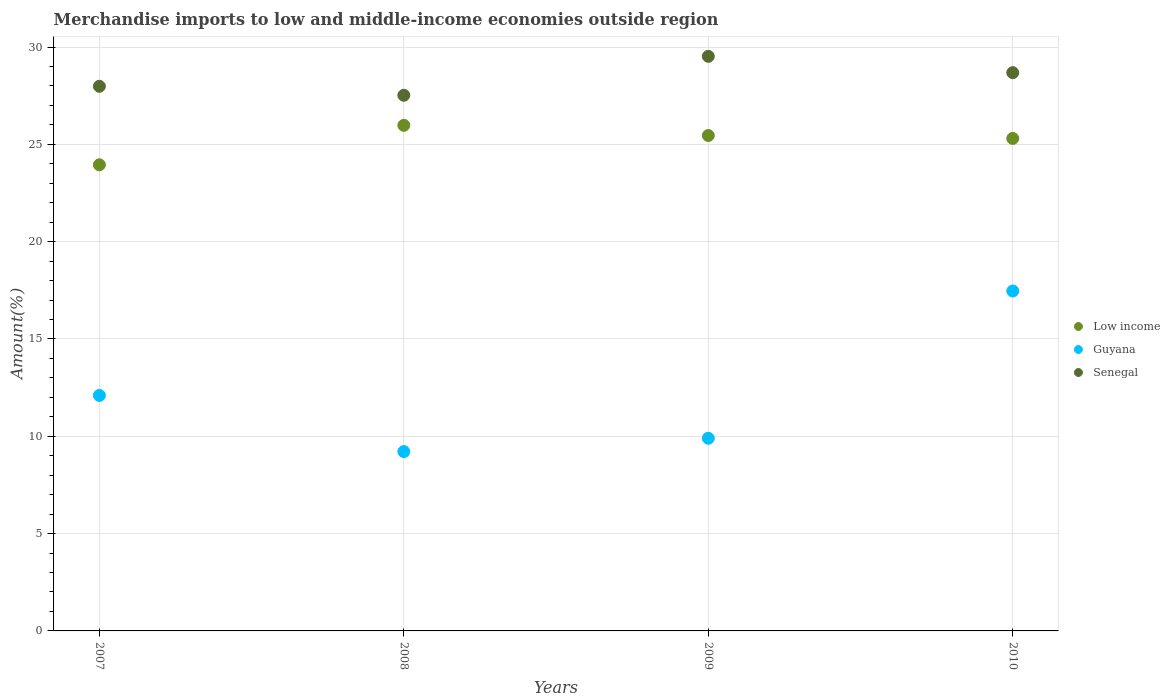How many different coloured dotlines are there?
Keep it short and to the point. 3. Is the number of dotlines equal to the number of legend labels?
Ensure brevity in your answer.  Yes. What is the percentage of amount earned from merchandise imports in Low income in 2008?
Offer a terse response. 25.98. Across all years, what is the maximum percentage of amount earned from merchandise imports in Senegal?
Provide a succinct answer. 29.52. Across all years, what is the minimum percentage of amount earned from merchandise imports in Guyana?
Keep it short and to the point. 9.22. In which year was the percentage of amount earned from merchandise imports in Senegal maximum?
Provide a succinct answer. 2009. In which year was the percentage of amount earned from merchandise imports in Guyana minimum?
Offer a very short reply. 2008. What is the total percentage of amount earned from merchandise imports in Low income in the graph?
Offer a terse response. 100.69. What is the difference between the percentage of amount earned from merchandise imports in Low income in 2009 and that in 2010?
Your answer should be compact. 0.15. What is the difference between the percentage of amount earned from merchandise imports in Low income in 2009 and the percentage of amount earned from merchandise imports in Guyana in 2008?
Your answer should be compact. 16.24. What is the average percentage of amount earned from merchandise imports in Low income per year?
Give a very brief answer. 25.17. In the year 2010, what is the difference between the percentage of amount earned from merchandise imports in Senegal and percentage of amount earned from merchandise imports in Guyana?
Give a very brief answer. 11.22. In how many years, is the percentage of amount earned from merchandise imports in Guyana greater than 28 %?
Give a very brief answer. 0. What is the ratio of the percentage of amount earned from merchandise imports in Guyana in 2009 to that in 2010?
Give a very brief answer. 0.57. Is the percentage of amount earned from merchandise imports in Senegal in 2007 less than that in 2009?
Offer a very short reply. Yes. Is the difference between the percentage of amount earned from merchandise imports in Senegal in 2008 and 2009 greater than the difference between the percentage of amount earned from merchandise imports in Guyana in 2008 and 2009?
Make the answer very short. No. What is the difference between the highest and the second highest percentage of amount earned from merchandise imports in Guyana?
Your response must be concise. 5.37. What is the difference between the highest and the lowest percentage of amount earned from merchandise imports in Guyana?
Provide a succinct answer. 8.25. In how many years, is the percentage of amount earned from merchandise imports in Low income greater than the average percentage of amount earned from merchandise imports in Low income taken over all years?
Make the answer very short. 3. Does the percentage of amount earned from merchandise imports in Guyana monotonically increase over the years?
Offer a very short reply. No. Is the percentage of amount earned from merchandise imports in Senegal strictly less than the percentage of amount earned from merchandise imports in Low income over the years?
Your response must be concise. No. How many years are there in the graph?
Make the answer very short. 4. Are the values on the major ticks of Y-axis written in scientific E-notation?
Give a very brief answer. No. How many legend labels are there?
Offer a terse response. 3. How are the legend labels stacked?
Make the answer very short. Vertical. What is the title of the graph?
Your answer should be very brief. Merchandise imports to low and middle-income economies outside region. Does "Namibia" appear as one of the legend labels in the graph?
Provide a succinct answer. No. What is the label or title of the X-axis?
Your answer should be compact. Years. What is the label or title of the Y-axis?
Provide a succinct answer. Amount(%). What is the Amount(%) of Low income in 2007?
Offer a very short reply. 23.95. What is the Amount(%) in Guyana in 2007?
Ensure brevity in your answer.  12.1. What is the Amount(%) in Senegal in 2007?
Provide a short and direct response. 27.99. What is the Amount(%) in Low income in 2008?
Make the answer very short. 25.98. What is the Amount(%) in Guyana in 2008?
Your answer should be compact. 9.22. What is the Amount(%) in Senegal in 2008?
Provide a succinct answer. 27.52. What is the Amount(%) in Low income in 2009?
Give a very brief answer. 25.46. What is the Amount(%) in Guyana in 2009?
Provide a succinct answer. 9.9. What is the Amount(%) of Senegal in 2009?
Make the answer very short. 29.52. What is the Amount(%) of Low income in 2010?
Your answer should be very brief. 25.31. What is the Amount(%) in Guyana in 2010?
Keep it short and to the point. 17.47. What is the Amount(%) in Senegal in 2010?
Your response must be concise. 28.69. Across all years, what is the maximum Amount(%) of Low income?
Give a very brief answer. 25.98. Across all years, what is the maximum Amount(%) of Guyana?
Keep it short and to the point. 17.47. Across all years, what is the maximum Amount(%) in Senegal?
Keep it short and to the point. 29.52. Across all years, what is the minimum Amount(%) in Low income?
Provide a succinct answer. 23.95. Across all years, what is the minimum Amount(%) of Guyana?
Your answer should be compact. 9.22. Across all years, what is the minimum Amount(%) in Senegal?
Make the answer very short. 27.52. What is the total Amount(%) of Low income in the graph?
Your response must be concise. 100.69. What is the total Amount(%) of Guyana in the graph?
Provide a succinct answer. 48.68. What is the total Amount(%) in Senegal in the graph?
Provide a short and direct response. 113.72. What is the difference between the Amount(%) of Low income in 2007 and that in 2008?
Ensure brevity in your answer.  -2.03. What is the difference between the Amount(%) of Guyana in 2007 and that in 2008?
Offer a very short reply. 2.88. What is the difference between the Amount(%) of Senegal in 2007 and that in 2008?
Your answer should be compact. 0.46. What is the difference between the Amount(%) in Low income in 2007 and that in 2009?
Offer a very short reply. -1.5. What is the difference between the Amount(%) of Guyana in 2007 and that in 2009?
Provide a short and direct response. 2.2. What is the difference between the Amount(%) of Senegal in 2007 and that in 2009?
Your answer should be very brief. -1.54. What is the difference between the Amount(%) of Low income in 2007 and that in 2010?
Your answer should be compact. -1.35. What is the difference between the Amount(%) in Guyana in 2007 and that in 2010?
Keep it short and to the point. -5.37. What is the difference between the Amount(%) of Senegal in 2007 and that in 2010?
Provide a short and direct response. -0.7. What is the difference between the Amount(%) of Low income in 2008 and that in 2009?
Offer a terse response. 0.52. What is the difference between the Amount(%) of Guyana in 2008 and that in 2009?
Give a very brief answer. -0.68. What is the difference between the Amount(%) in Senegal in 2008 and that in 2009?
Make the answer very short. -2. What is the difference between the Amount(%) in Low income in 2008 and that in 2010?
Offer a very short reply. 0.67. What is the difference between the Amount(%) of Guyana in 2008 and that in 2010?
Keep it short and to the point. -8.25. What is the difference between the Amount(%) of Senegal in 2008 and that in 2010?
Give a very brief answer. -1.16. What is the difference between the Amount(%) of Low income in 2009 and that in 2010?
Offer a terse response. 0.15. What is the difference between the Amount(%) of Guyana in 2009 and that in 2010?
Your answer should be very brief. -7.57. What is the difference between the Amount(%) in Senegal in 2009 and that in 2010?
Offer a terse response. 0.84. What is the difference between the Amount(%) in Low income in 2007 and the Amount(%) in Guyana in 2008?
Your answer should be very brief. 14.73. What is the difference between the Amount(%) of Low income in 2007 and the Amount(%) of Senegal in 2008?
Your response must be concise. -3.57. What is the difference between the Amount(%) of Guyana in 2007 and the Amount(%) of Senegal in 2008?
Ensure brevity in your answer.  -15.42. What is the difference between the Amount(%) in Low income in 2007 and the Amount(%) in Guyana in 2009?
Give a very brief answer. 14.05. What is the difference between the Amount(%) of Low income in 2007 and the Amount(%) of Senegal in 2009?
Make the answer very short. -5.57. What is the difference between the Amount(%) of Guyana in 2007 and the Amount(%) of Senegal in 2009?
Your response must be concise. -17.42. What is the difference between the Amount(%) of Low income in 2007 and the Amount(%) of Guyana in 2010?
Provide a short and direct response. 6.48. What is the difference between the Amount(%) of Low income in 2007 and the Amount(%) of Senegal in 2010?
Give a very brief answer. -4.73. What is the difference between the Amount(%) in Guyana in 2007 and the Amount(%) in Senegal in 2010?
Provide a succinct answer. -16.58. What is the difference between the Amount(%) in Low income in 2008 and the Amount(%) in Guyana in 2009?
Your response must be concise. 16.08. What is the difference between the Amount(%) of Low income in 2008 and the Amount(%) of Senegal in 2009?
Offer a terse response. -3.54. What is the difference between the Amount(%) of Guyana in 2008 and the Amount(%) of Senegal in 2009?
Ensure brevity in your answer.  -20.31. What is the difference between the Amount(%) in Low income in 2008 and the Amount(%) in Guyana in 2010?
Ensure brevity in your answer.  8.51. What is the difference between the Amount(%) of Low income in 2008 and the Amount(%) of Senegal in 2010?
Give a very brief answer. -2.71. What is the difference between the Amount(%) of Guyana in 2008 and the Amount(%) of Senegal in 2010?
Offer a terse response. -19.47. What is the difference between the Amount(%) in Low income in 2009 and the Amount(%) in Guyana in 2010?
Keep it short and to the point. 7.99. What is the difference between the Amount(%) of Low income in 2009 and the Amount(%) of Senegal in 2010?
Your answer should be compact. -3.23. What is the difference between the Amount(%) of Guyana in 2009 and the Amount(%) of Senegal in 2010?
Provide a succinct answer. -18.79. What is the average Amount(%) in Low income per year?
Provide a short and direct response. 25.17. What is the average Amount(%) in Guyana per year?
Give a very brief answer. 12.17. What is the average Amount(%) of Senegal per year?
Offer a very short reply. 28.43. In the year 2007, what is the difference between the Amount(%) of Low income and Amount(%) of Guyana?
Your answer should be compact. 11.85. In the year 2007, what is the difference between the Amount(%) of Low income and Amount(%) of Senegal?
Your answer should be compact. -4.03. In the year 2007, what is the difference between the Amount(%) in Guyana and Amount(%) in Senegal?
Give a very brief answer. -15.88. In the year 2008, what is the difference between the Amount(%) in Low income and Amount(%) in Guyana?
Provide a succinct answer. 16.76. In the year 2008, what is the difference between the Amount(%) in Low income and Amount(%) in Senegal?
Your answer should be compact. -1.54. In the year 2008, what is the difference between the Amount(%) of Guyana and Amount(%) of Senegal?
Provide a short and direct response. -18.31. In the year 2009, what is the difference between the Amount(%) in Low income and Amount(%) in Guyana?
Make the answer very short. 15.56. In the year 2009, what is the difference between the Amount(%) of Low income and Amount(%) of Senegal?
Your response must be concise. -4.07. In the year 2009, what is the difference between the Amount(%) of Guyana and Amount(%) of Senegal?
Your answer should be compact. -19.62. In the year 2010, what is the difference between the Amount(%) in Low income and Amount(%) in Guyana?
Offer a terse response. 7.84. In the year 2010, what is the difference between the Amount(%) in Low income and Amount(%) in Senegal?
Your answer should be very brief. -3.38. In the year 2010, what is the difference between the Amount(%) in Guyana and Amount(%) in Senegal?
Your response must be concise. -11.22. What is the ratio of the Amount(%) of Low income in 2007 to that in 2008?
Offer a very short reply. 0.92. What is the ratio of the Amount(%) of Guyana in 2007 to that in 2008?
Your response must be concise. 1.31. What is the ratio of the Amount(%) of Senegal in 2007 to that in 2008?
Offer a very short reply. 1.02. What is the ratio of the Amount(%) in Low income in 2007 to that in 2009?
Your response must be concise. 0.94. What is the ratio of the Amount(%) in Guyana in 2007 to that in 2009?
Offer a terse response. 1.22. What is the ratio of the Amount(%) of Senegal in 2007 to that in 2009?
Make the answer very short. 0.95. What is the ratio of the Amount(%) in Low income in 2007 to that in 2010?
Your response must be concise. 0.95. What is the ratio of the Amount(%) in Guyana in 2007 to that in 2010?
Keep it short and to the point. 0.69. What is the ratio of the Amount(%) of Senegal in 2007 to that in 2010?
Your answer should be very brief. 0.98. What is the ratio of the Amount(%) of Low income in 2008 to that in 2009?
Offer a very short reply. 1.02. What is the ratio of the Amount(%) in Senegal in 2008 to that in 2009?
Your answer should be compact. 0.93. What is the ratio of the Amount(%) in Low income in 2008 to that in 2010?
Your response must be concise. 1.03. What is the ratio of the Amount(%) of Guyana in 2008 to that in 2010?
Provide a short and direct response. 0.53. What is the ratio of the Amount(%) in Senegal in 2008 to that in 2010?
Your answer should be compact. 0.96. What is the ratio of the Amount(%) of Low income in 2009 to that in 2010?
Make the answer very short. 1.01. What is the ratio of the Amount(%) in Guyana in 2009 to that in 2010?
Give a very brief answer. 0.57. What is the ratio of the Amount(%) of Senegal in 2009 to that in 2010?
Provide a succinct answer. 1.03. What is the difference between the highest and the second highest Amount(%) in Low income?
Offer a very short reply. 0.52. What is the difference between the highest and the second highest Amount(%) in Guyana?
Ensure brevity in your answer.  5.37. What is the difference between the highest and the second highest Amount(%) of Senegal?
Provide a succinct answer. 0.84. What is the difference between the highest and the lowest Amount(%) in Low income?
Provide a short and direct response. 2.03. What is the difference between the highest and the lowest Amount(%) of Guyana?
Ensure brevity in your answer.  8.25. What is the difference between the highest and the lowest Amount(%) of Senegal?
Ensure brevity in your answer.  2. 